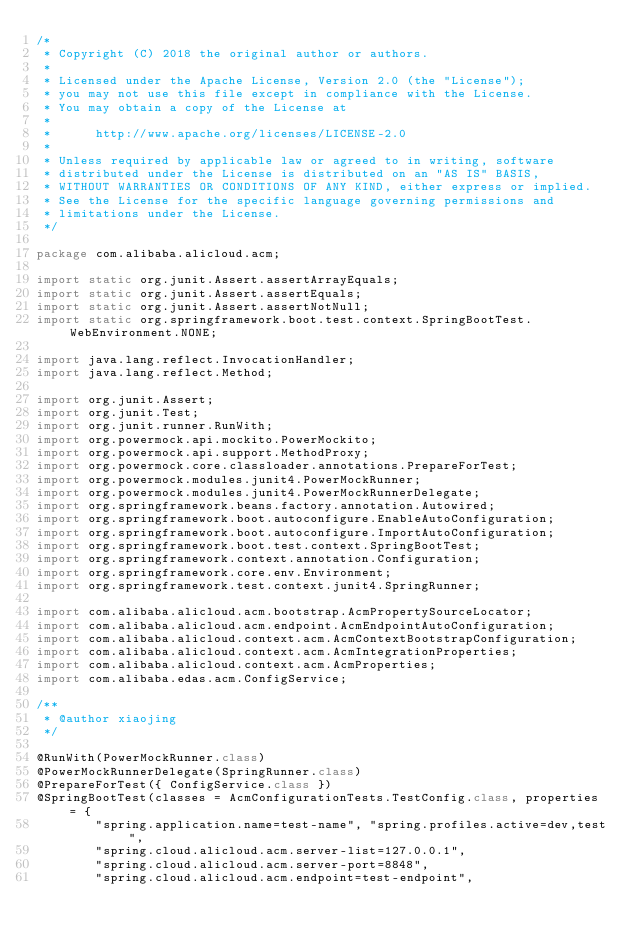<code> <loc_0><loc_0><loc_500><loc_500><_Java_>/*
 * Copyright (C) 2018 the original author or authors.
 *
 * Licensed under the Apache License, Version 2.0 (the "License");
 * you may not use this file except in compliance with the License.
 * You may obtain a copy of the License at
 *
 *      http://www.apache.org/licenses/LICENSE-2.0
 *
 * Unless required by applicable law or agreed to in writing, software
 * distributed under the License is distributed on an "AS IS" BASIS,
 * WITHOUT WARRANTIES OR CONDITIONS OF ANY KIND, either express or implied.
 * See the License for the specific language governing permissions and
 * limitations under the License.
 */

package com.alibaba.alicloud.acm;

import static org.junit.Assert.assertArrayEquals;
import static org.junit.Assert.assertEquals;
import static org.junit.Assert.assertNotNull;
import static org.springframework.boot.test.context.SpringBootTest.WebEnvironment.NONE;

import java.lang.reflect.InvocationHandler;
import java.lang.reflect.Method;

import org.junit.Assert;
import org.junit.Test;
import org.junit.runner.RunWith;
import org.powermock.api.mockito.PowerMockito;
import org.powermock.api.support.MethodProxy;
import org.powermock.core.classloader.annotations.PrepareForTest;
import org.powermock.modules.junit4.PowerMockRunner;
import org.powermock.modules.junit4.PowerMockRunnerDelegate;
import org.springframework.beans.factory.annotation.Autowired;
import org.springframework.boot.autoconfigure.EnableAutoConfiguration;
import org.springframework.boot.autoconfigure.ImportAutoConfiguration;
import org.springframework.boot.test.context.SpringBootTest;
import org.springframework.context.annotation.Configuration;
import org.springframework.core.env.Environment;
import org.springframework.test.context.junit4.SpringRunner;

import com.alibaba.alicloud.acm.bootstrap.AcmPropertySourceLocator;
import com.alibaba.alicloud.acm.endpoint.AcmEndpointAutoConfiguration;
import com.alibaba.alicloud.context.acm.AcmContextBootstrapConfiguration;
import com.alibaba.alicloud.context.acm.AcmIntegrationProperties;
import com.alibaba.alicloud.context.acm.AcmProperties;
import com.alibaba.edas.acm.ConfigService;

/**
 * @author xiaojing
 */

@RunWith(PowerMockRunner.class)
@PowerMockRunnerDelegate(SpringRunner.class)
@PrepareForTest({ ConfigService.class })
@SpringBootTest(classes = AcmConfigurationTests.TestConfig.class, properties = {
		"spring.application.name=test-name", "spring.profiles.active=dev,test",
		"spring.cloud.alicloud.acm.server-list=127.0.0.1",
		"spring.cloud.alicloud.acm.server-port=8848",
		"spring.cloud.alicloud.acm.endpoint=test-endpoint",</code> 